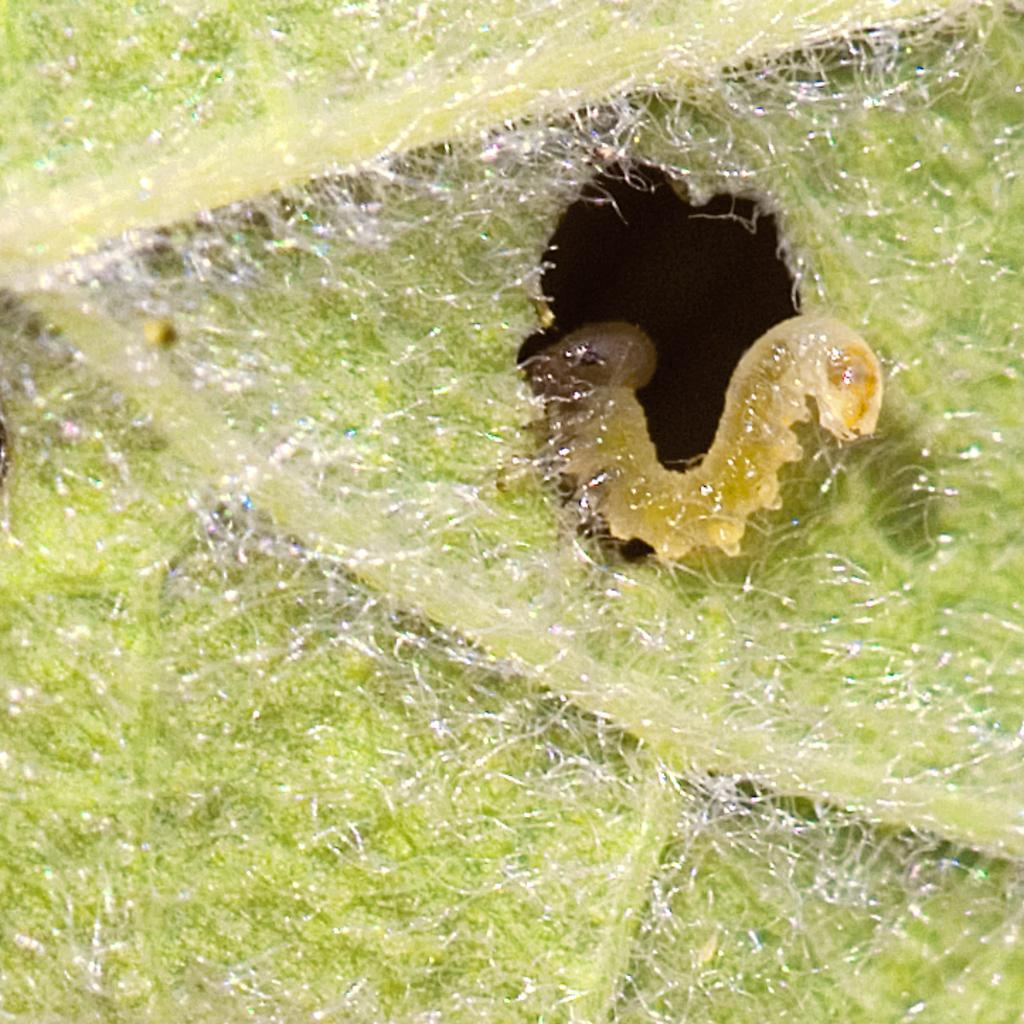What is present in the image? There is an insect in the image. Where is the insect located? The insect is on a leaf. How many rabbits can be seen playing on the stone in the image? There are no rabbits or stones present in the image; it features an insect on a leaf. 